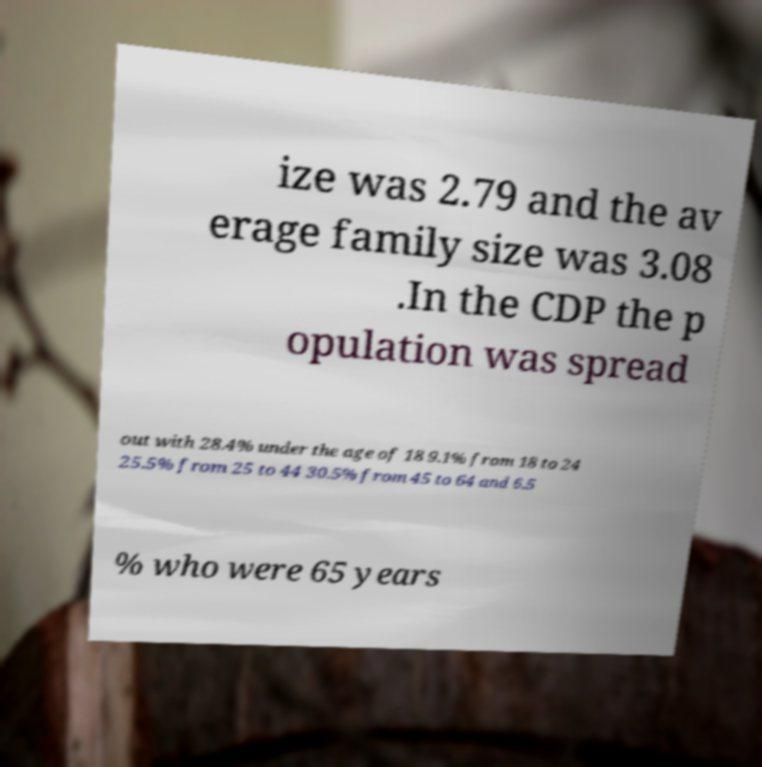Please read and relay the text visible in this image. What does it say? ize was 2.79 and the av erage family size was 3.08 .In the CDP the p opulation was spread out with 28.4% under the age of 18 9.1% from 18 to 24 25.5% from 25 to 44 30.5% from 45 to 64 and 6.5 % who were 65 years 